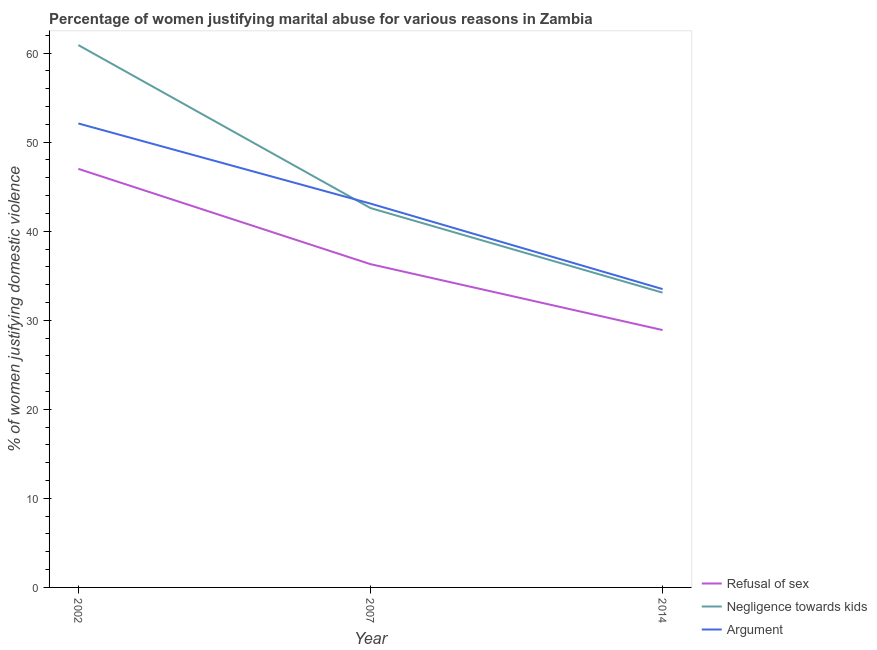Does the line corresponding to percentage of women justifying domestic violence due to refusal of sex intersect with the line corresponding to percentage of women justifying domestic violence due to arguments?
Offer a terse response. No. Is the number of lines equal to the number of legend labels?
Your answer should be compact. Yes. What is the percentage of women justifying domestic violence due to negligence towards kids in 2014?
Offer a terse response. 33.1. Across all years, what is the maximum percentage of women justifying domestic violence due to negligence towards kids?
Your answer should be very brief. 60.9. Across all years, what is the minimum percentage of women justifying domestic violence due to arguments?
Make the answer very short. 33.5. In which year was the percentage of women justifying domestic violence due to refusal of sex minimum?
Give a very brief answer. 2014. What is the total percentage of women justifying domestic violence due to arguments in the graph?
Ensure brevity in your answer.  128.7. What is the difference between the percentage of women justifying domestic violence due to refusal of sex in 2002 and that in 2007?
Provide a succinct answer. 10.7. What is the difference between the percentage of women justifying domestic violence due to arguments in 2014 and the percentage of women justifying domestic violence due to negligence towards kids in 2002?
Give a very brief answer. -27.4. What is the average percentage of women justifying domestic violence due to negligence towards kids per year?
Offer a very short reply. 45.53. In the year 2007, what is the difference between the percentage of women justifying domestic violence due to refusal of sex and percentage of women justifying domestic violence due to arguments?
Ensure brevity in your answer.  -6.8. What is the ratio of the percentage of women justifying domestic violence due to arguments in 2007 to that in 2014?
Offer a very short reply. 1.29. What is the difference between the highest and the second highest percentage of women justifying domestic violence due to refusal of sex?
Your answer should be very brief. 10.7. What is the difference between the highest and the lowest percentage of women justifying domestic violence due to refusal of sex?
Keep it short and to the point. 18.1. Does the percentage of women justifying domestic violence due to negligence towards kids monotonically increase over the years?
Your response must be concise. No. Is the percentage of women justifying domestic violence due to refusal of sex strictly greater than the percentage of women justifying domestic violence due to negligence towards kids over the years?
Offer a terse response. No. Are the values on the major ticks of Y-axis written in scientific E-notation?
Keep it short and to the point. No. Does the graph contain any zero values?
Keep it short and to the point. No. Where does the legend appear in the graph?
Your answer should be compact. Bottom right. How many legend labels are there?
Your answer should be compact. 3. How are the legend labels stacked?
Make the answer very short. Vertical. What is the title of the graph?
Your answer should be very brief. Percentage of women justifying marital abuse for various reasons in Zambia. What is the label or title of the X-axis?
Your answer should be very brief. Year. What is the label or title of the Y-axis?
Keep it short and to the point. % of women justifying domestic violence. What is the % of women justifying domestic violence in Refusal of sex in 2002?
Offer a terse response. 47. What is the % of women justifying domestic violence in Negligence towards kids in 2002?
Your response must be concise. 60.9. What is the % of women justifying domestic violence in Argument in 2002?
Your answer should be compact. 52.1. What is the % of women justifying domestic violence of Refusal of sex in 2007?
Your answer should be very brief. 36.3. What is the % of women justifying domestic violence of Negligence towards kids in 2007?
Provide a succinct answer. 42.6. What is the % of women justifying domestic violence of Argument in 2007?
Your answer should be very brief. 43.1. What is the % of women justifying domestic violence in Refusal of sex in 2014?
Your answer should be compact. 28.9. What is the % of women justifying domestic violence in Negligence towards kids in 2014?
Make the answer very short. 33.1. What is the % of women justifying domestic violence in Argument in 2014?
Offer a very short reply. 33.5. Across all years, what is the maximum % of women justifying domestic violence of Negligence towards kids?
Your answer should be very brief. 60.9. Across all years, what is the maximum % of women justifying domestic violence in Argument?
Give a very brief answer. 52.1. Across all years, what is the minimum % of women justifying domestic violence in Refusal of sex?
Make the answer very short. 28.9. Across all years, what is the minimum % of women justifying domestic violence in Negligence towards kids?
Make the answer very short. 33.1. Across all years, what is the minimum % of women justifying domestic violence in Argument?
Your answer should be compact. 33.5. What is the total % of women justifying domestic violence of Refusal of sex in the graph?
Give a very brief answer. 112.2. What is the total % of women justifying domestic violence in Negligence towards kids in the graph?
Your response must be concise. 136.6. What is the total % of women justifying domestic violence of Argument in the graph?
Offer a terse response. 128.7. What is the difference between the % of women justifying domestic violence of Argument in 2002 and that in 2007?
Your answer should be very brief. 9. What is the difference between the % of women justifying domestic violence of Negligence towards kids in 2002 and that in 2014?
Offer a terse response. 27.8. What is the difference between the % of women justifying domestic violence of Argument in 2002 and that in 2014?
Your response must be concise. 18.6. What is the difference between the % of women justifying domestic violence of Negligence towards kids in 2007 and that in 2014?
Give a very brief answer. 9.5. What is the difference between the % of women justifying domestic violence in Argument in 2007 and that in 2014?
Your answer should be compact. 9.6. What is the difference between the % of women justifying domestic violence of Negligence towards kids in 2002 and the % of women justifying domestic violence of Argument in 2007?
Your answer should be very brief. 17.8. What is the difference between the % of women justifying domestic violence of Refusal of sex in 2002 and the % of women justifying domestic violence of Negligence towards kids in 2014?
Provide a short and direct response. 13.9. What is the difference between the % of women justifying domestic violence in Negligence towards kids in 2002 and the % of women justifying domestic violence in Argument in 2014?
Keep it short and to the point. 27.4. What is the difference between the % of women justifying domestic violence of Negligence towards kids in 2007 and the % of women justifying domestic violence of Argument in 2014?
Offer a terse response. 9.1. What is the average % of women justifying domestic violence in Refusal of sex per year?
Offer a terse response. 37.4. What is the average % of women justifying domestic violence in Negligence towards kids per year?
Offer a very short reply. 45.53. What is the average % of women justifying domestic violence in Argument per year?
Offer a very short reply. 42.9. In the year 2002, what is the difference between the % of women justifying domestic violence of Refusal of sex and % of women justifying domestic violence of Argument?
Give a very brief answer. -5.1. In the year 2002, what is the difference between the % of women justifying domestic violence in Negligence towards kids and % of women justifying domestic violence in Argument?
Your response must be concise. 8.8. In the year 2007, what is the difference between the % of women justifying domestic violence of Refusal of sex and % of women justifying domestic violence of Argument?
Offer a very short reply. -6.8. In the year 2014, what is the difference between the % of women justifying domestic violence in Negligence towards kids and % of women justifying domestic violence in Argument?
Keep it short and to the point. -0.4. What is the ratio of the % of women justifying domestic violence in Refusal of sex in 2002 to that in 2007?
Offer a terse response. 1.29. What is the ratio of the % of women justifying domestic violence in Negligence towards kids in 2002 to that in 2007?
Keep it short and to the point. 1.43. What is the ratio of the % of women justifying domestic violence in Argument in 2002 to that in 2007?
Your answer should be compact. 1.21. What is the ratio of the % of women justifying domestic violence in Refusal of sex in 2002 to that in 2014?
Offer a very short reply. 1.63. What is the ratio of the % of women justifying domestic violence of Negligence towards kids in 2002 to that in 2014?
Offer a terse response. 1.84. What is the ratio of the % of women justifying domestic violence in Argument in 2002 to that in 2014?
Your response must be concise. 1.56. What is the ratio of the % of women justifying domestic violence of Refusal of sex in 2007 to that in 2014?
Offer a very short reply. 1.26. What is the ratio of the % of women justifying domestic violence in Negligence towards kids in 2007 to that in 2014?
Offer a very short reply. 1.29. What is the ratio of the % of women justifying domestic violence in Argument in 2007 to that in 2014?
Offer a terse response. 1.29. What is the difference between the highest and the second highest % of women justifying domestic violence in Negligence towards kids?
Provide a succinct answer. 18.3. What is the difference between the highest and the second highest % of women justifying domestic violence in Argument?
Make the answer very short. 9. What is the difference between the highest and the lowest % of women justifying domestic violence in Refusal of sex?
Provide a short and direct response. 18.1. What is the difference between the highest and the lowest % of women justifying domestic violence in Negligence towards kids?
Make the answer very short. 27.8. What is the difference between the highest and the lowest % of women justifying domestic violence of Argument?
Make the answer very short. 18.6. 